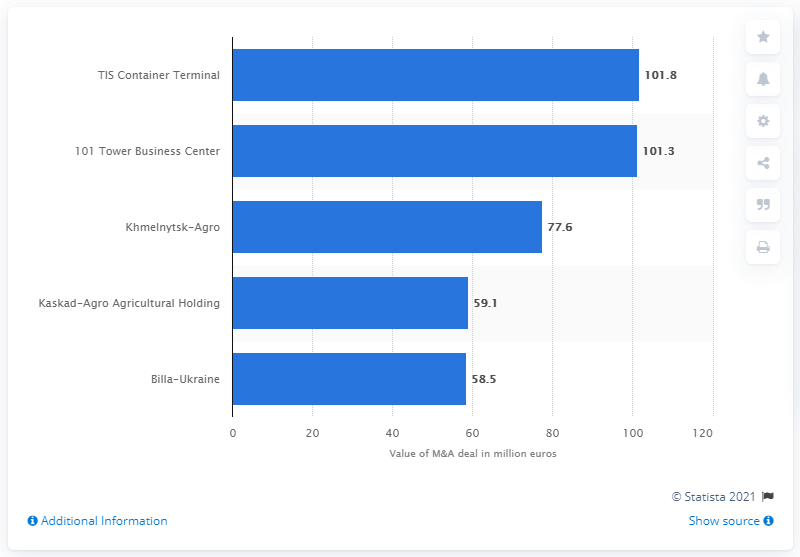What was the value of Billa-Ukraine? The value of Billa-Ukraine, according to the bar graph from 2021, is 58.5 million euros. This places it as one of the significant mergers and acquisitions in the visual data, closely following behind Kaskad-Agro Agricultural Holding. 